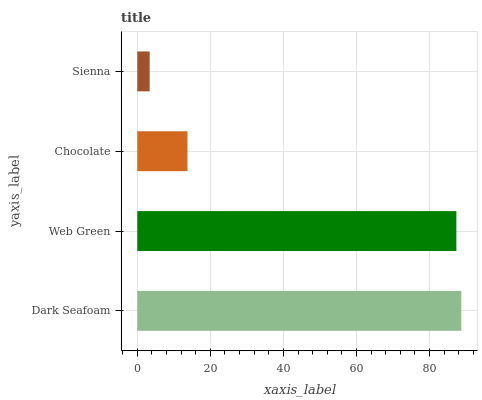Is Sienna the minimum?
Answer yes or no. Yes. Is Dark Seafoam the maximum?
Answer yes or no. Yes. Is Web Green the minimum?
Answer yes or no. No. Is Web Green the maximum?
Answer yes or no. No. Is Dark Seafoam greater than Web Green?
Answer yes or no. Yes. Is Web Green less than Dark Seafoam?
Answer yes or no. Yes. Is Web Green greater than Dark Seafoam?
Answer yes or no. No. Is Dark Seafoam less than Web Green?
Answer yes or no. No. Is Web Green the high median?
Answer yes or no. Yes. Is Chocolate the low median?
Answer yes or no. Yes. Is Dark Seafoam the high median?
Answer yes or no. No. Is Sienna the low median?
Answer yes or no. No. 